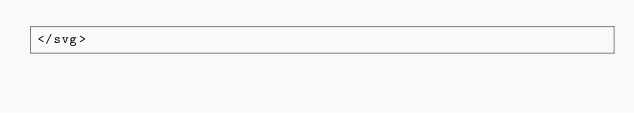Convert code to text. <code><loc_0><loc_0><loc_500><loc_500><_XML_></svg>
</code> 